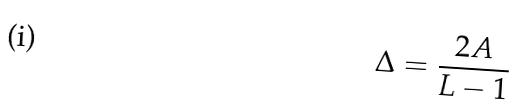Convert formula to latex. <formula><loc_0><loc_0><loc_500><loc_500>\Delta = \frac { 2 A } { L - 1 }</formula> 